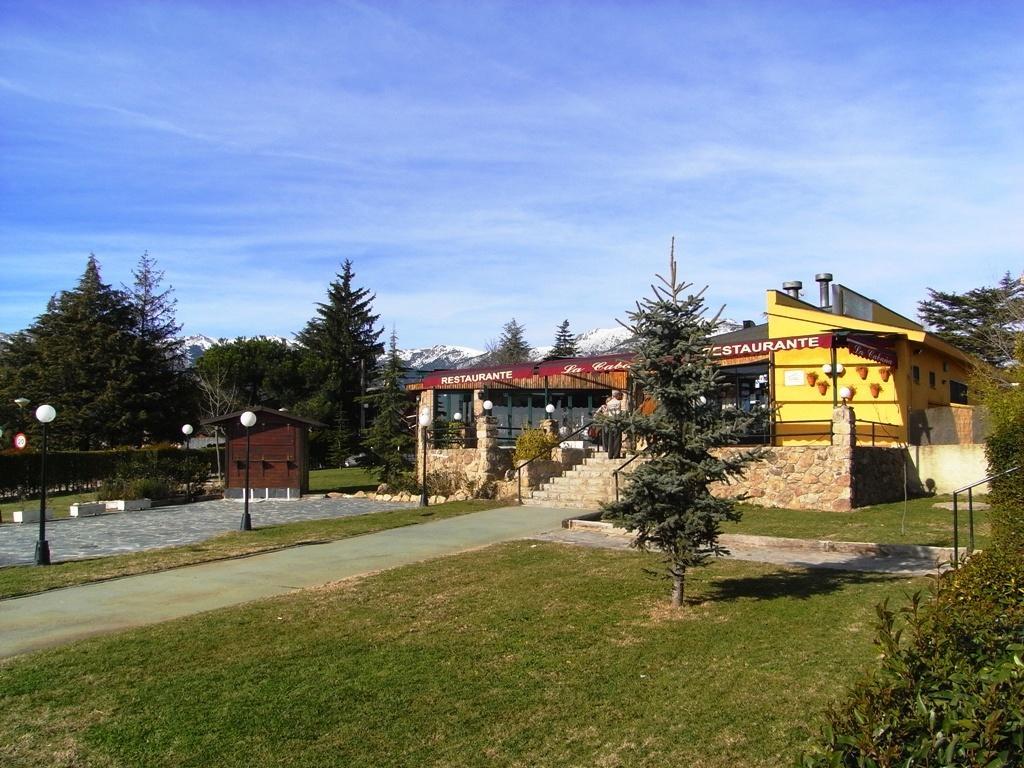In one or two sentences, can you explain what this image depicts? In this picture we can see the grass, path, shade, trees, poles, lights, building, banners, steps, walls and in the background we can see the sky with clouds. 